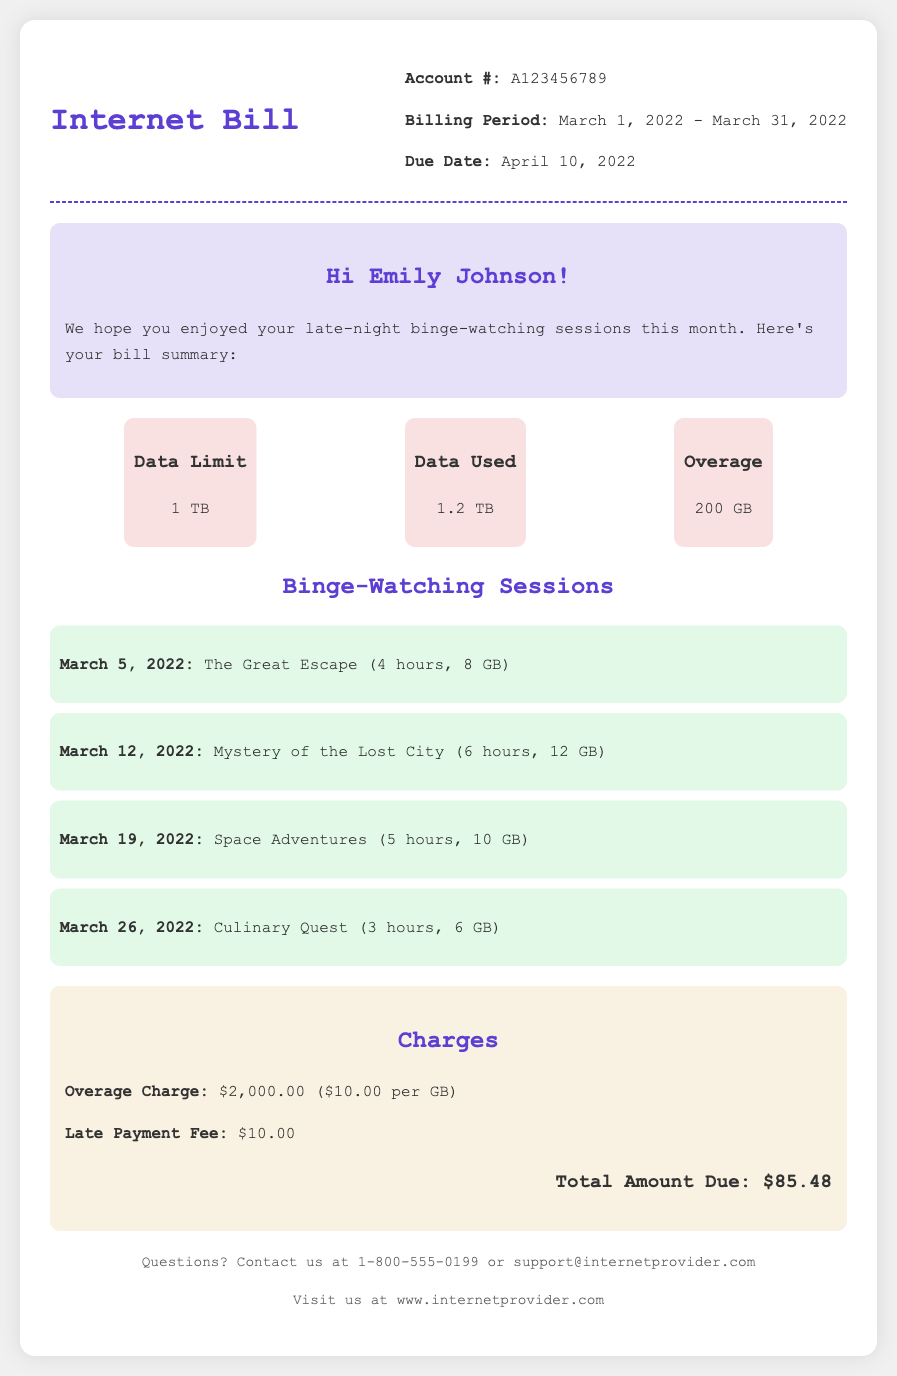What is the billing period? The billing period is clearly stated in the document as from March 1, 2022 to March 31, 2022.
Answer: March 1, 2022 - March 31, 2022 How much data was used this month? The document specifies the amount of data used as 1.2 TB.
Answer: 1.2 TB What is the overage charge? The document lists the overage charge amount to be $2,000.00 for exceeding the data limit.
Answer: $2,000.00 How many binge-watching sessions are listed? The document includes a summary of binge-watching sessions, which totals four.
Answer: 4 What is the total amount due? The total amount due is the final figure presented in the charges section of the document, which is $85.48.
Answer: $85.48 What is the data limit? The data limit mentioned in the document for the month is 1 TB.
Answer: 1 TB When is the due date? The due date is provided in the bill and is April 10, 2022.
Answer: April 10, 2022 What was the highest data consumption in a binge-watching session? The highest data consumption from the listed sessions is 12 GB for the session dated March 12, 2022.
Answer: 12 GB Is there a late payment fee? The document confirms that there is a late payment fee stated in the charges section.
Answer: Yes 